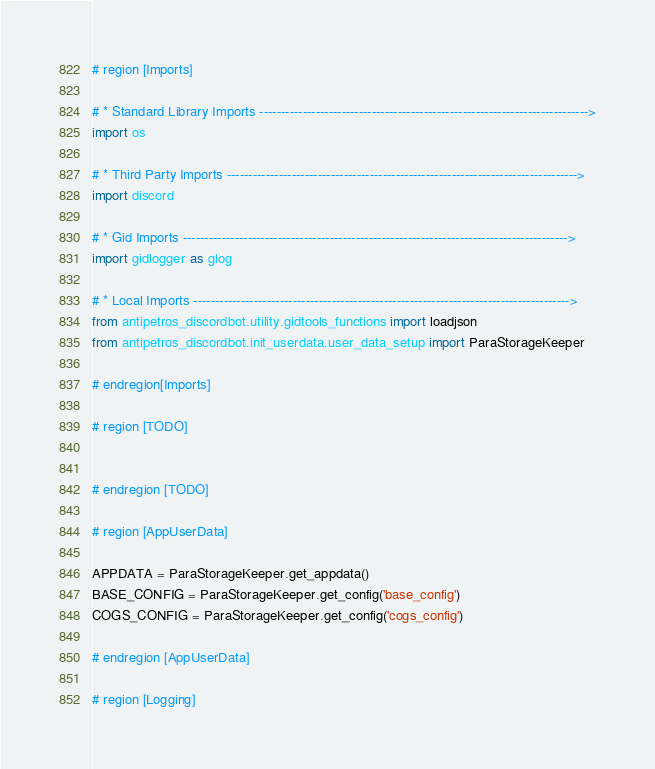<code> <loc_0><loc_0><loc_500><loc_500><_Python_>

# region [Imports]

# * Standard Library Imports ---------------------------------------------------------------------------->
import os

# * Third Party Imports --------------------------------------------------------------------------------->
import discord

# * Gid Imports ----------------------------------------------------------------------------------------->
import gidlogger as glog

# * Local Imports --------------------------------------------------------------------------------------->
from antipetros_discordbot.utility.gidtools_functions import loadjson
from antipetros_discordbot.init_userdata.user_data_setup import ParaStorageKeeper

# endregion[Imports]

# region [TODO]


# endregion [TODO]

# region [AppUserData]

APPDATA = ParaStorageKeeper.get_appdata()
BASE_CONFIG = ParaStorageKeeper.get_config('base_config')
COGS_CONFIG = ParaStorageKeeper.get_config('cogs_config')

# endregion [AppUserData]

# region [Logging]
</code> 